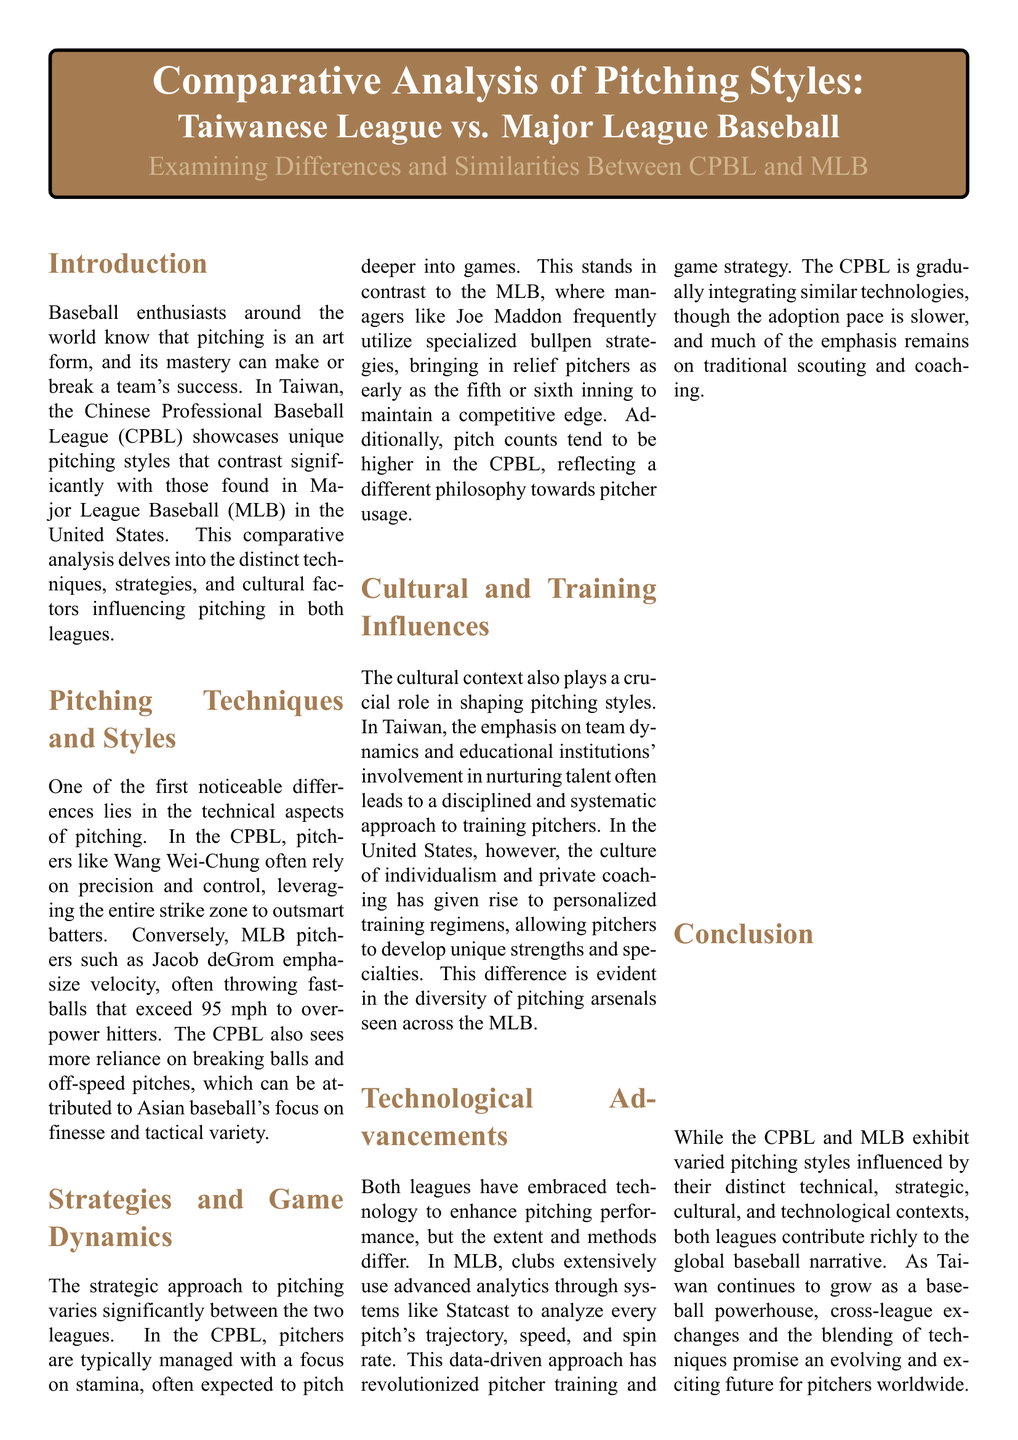What is the primary focus of the document? The document focuses on comparing pitching styles in the Taiwanese league (CPBL) and Major League Baseball (MLB).
Answer: Comparative Analysis of Pitching Styles Who is a notable pitcher from the CPBL? The document mentions Wang Wei-Chung as a notable pitcher representing the CPBL.
Answer: Wang Wei-Chung What is the average fastball speed in MLB? The document provides specific metrics and states the average fastball speed in MLB.
Answer: 92-97 mph What percentage is the strikeout rate in the CPBL? The document lists the strikeout rate applicable to the CPBL's pitching metrics.
Answer: 20% How does pitch count per game differ between CPBL and MLB? The document highlights the differences in pitch count, indicating a higher count average in CPBL.
Answer: 90-110 What technique does Jacob deGrom exemplify? The document describes Jacob deGrom’s pitching style as reflecting power pitching.
Answer: Power pitching What does Chien-Ming Wang suggest about MLB techniques? Chien-Ming Wang emphasizes the importance of adapting MLB techniques for CPBL gameplay.
Answer: Adapting MLB techniques What cultural factor influences pitching styles in Taiwan? The document mentions team dynamics as a cultural factor influencing pitching styles in Taiwan.
Answer: Team dynamics What is the main difference in bullpen strategy between CPBL and MLB? The document notes that MLB managers often use specialized bullpen strategies more frequently than CPBL.
Answer: Specialized bullpen strategies 